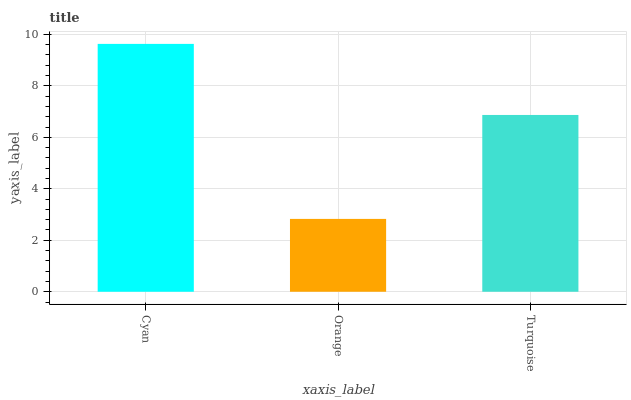Is Orange the minimum?
Answer yes or no. Yes. Is Cyan the maximum?
Answer yes or no. Yes. Is Turquoise the minimum?
Answer yes or no. No. Is Turquoise the maximum?
Answer yes or no. No. Is Turquoise greater than Orange?
Answer yes or no. Yes. Is Orange less than Turquoise?
Answer yes or no. Yes. Is Orange greater than Turquoise?
Answer yes or no. No. Is Turquoise less than Orange?
Answer yes or no. No. Is Turquoise the high median?
Answer yes or no. Yes. Is Turquoise the low median?
Answer yes or no. Yes. Is Orange the high median?
Answer yes or no. No. Is Orange the low median?
Answer yes or no. No. 